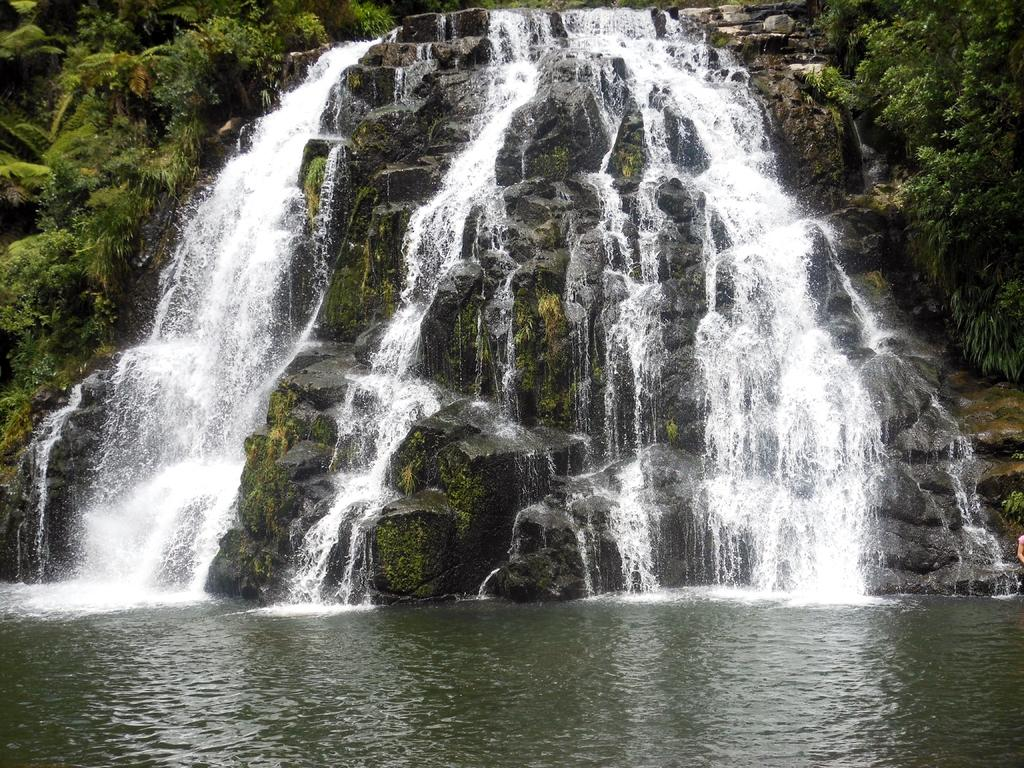What is the main subject of the image? There is a rock in the image. What is happening to the rock? Water is falling over the rock. What can be seen on both sides of the rock? There are trees on both sides of the rock. What is visible at the bottom of the image? There is water visible at the bottom of the image. Whose hand is visible in the image? A person's hand is visible on the right side of the image. What type of support can be seen holding up the icicle in the image? There is no icicle present in the image, so there is no support for it. 